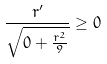Convert formula to latex. <formula><loc_0><loc_0><loc_500><loc_500>\frac { r ^ { \prime } } { \sqrt { 0 + \frac { r ^ { 2 } } { 9 } } } \geq 0</formula> 